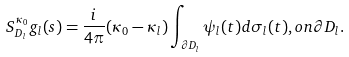<formula> <loc_0><loc_0><loc_500><loc_500>S ^ { \kappa _ { 0 } } _ { D _ { l } } g _ { l } ( s ) = \frac { i } { 4 \pi } ( \kappa _ { 0 } - \kappa _ { l } ) \int _ { \partial D _ { l } } \psi _ { l } ( t ) d \sigma _ { l } ( t ) , o n \partial D _ { l } .</formula> 